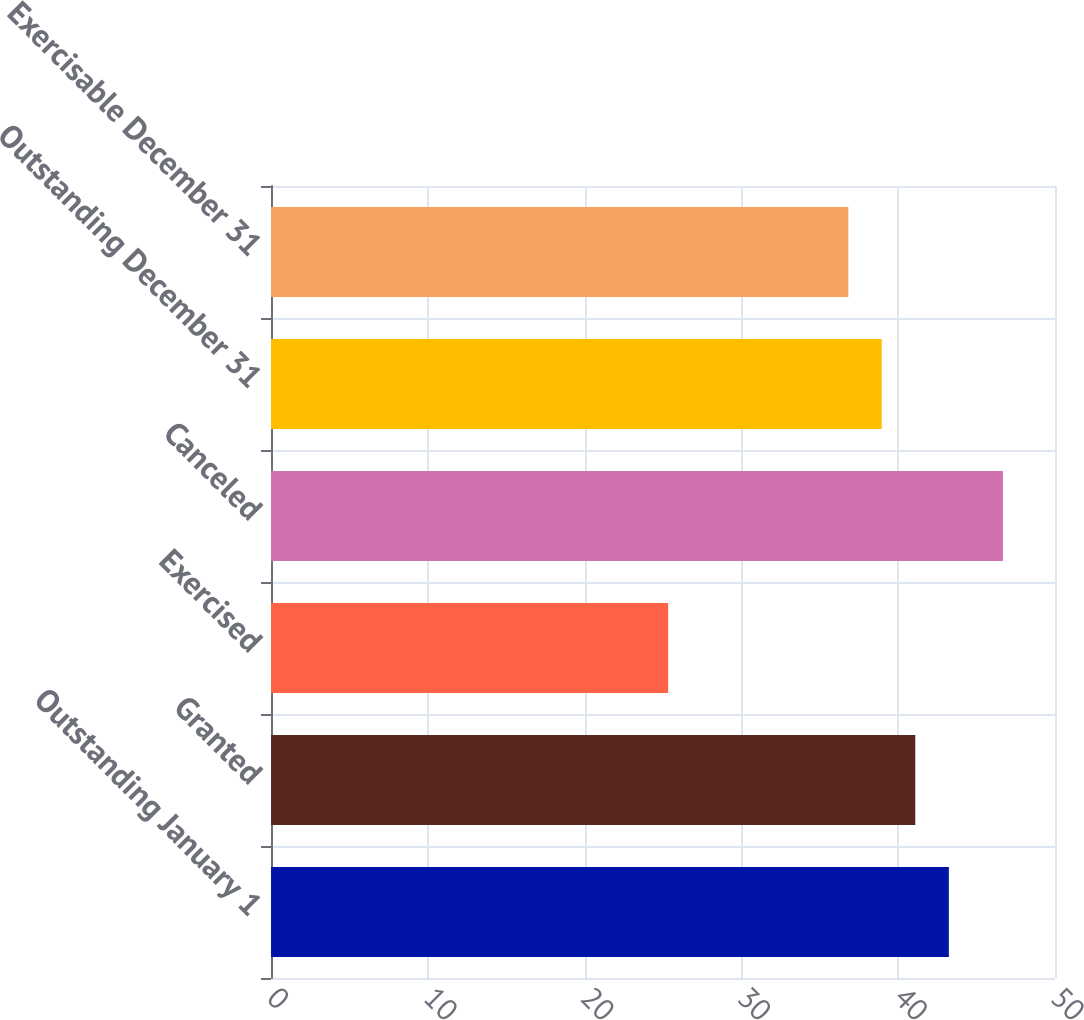<chart> <loc_0><loc_0><loc_500><loc_500><bar_chart><fcel>Outstanding January 1<fcel>Granted<fcel>Exercised<fcel>Canceled<fcel>Outstanding December 31<fcel>Exercisable December 31<nl><fcel>43.23<fcel>41.09<fcel>25.33<fcel>46.68<fcel>38.95<fcel>36.82<nl></chart> 